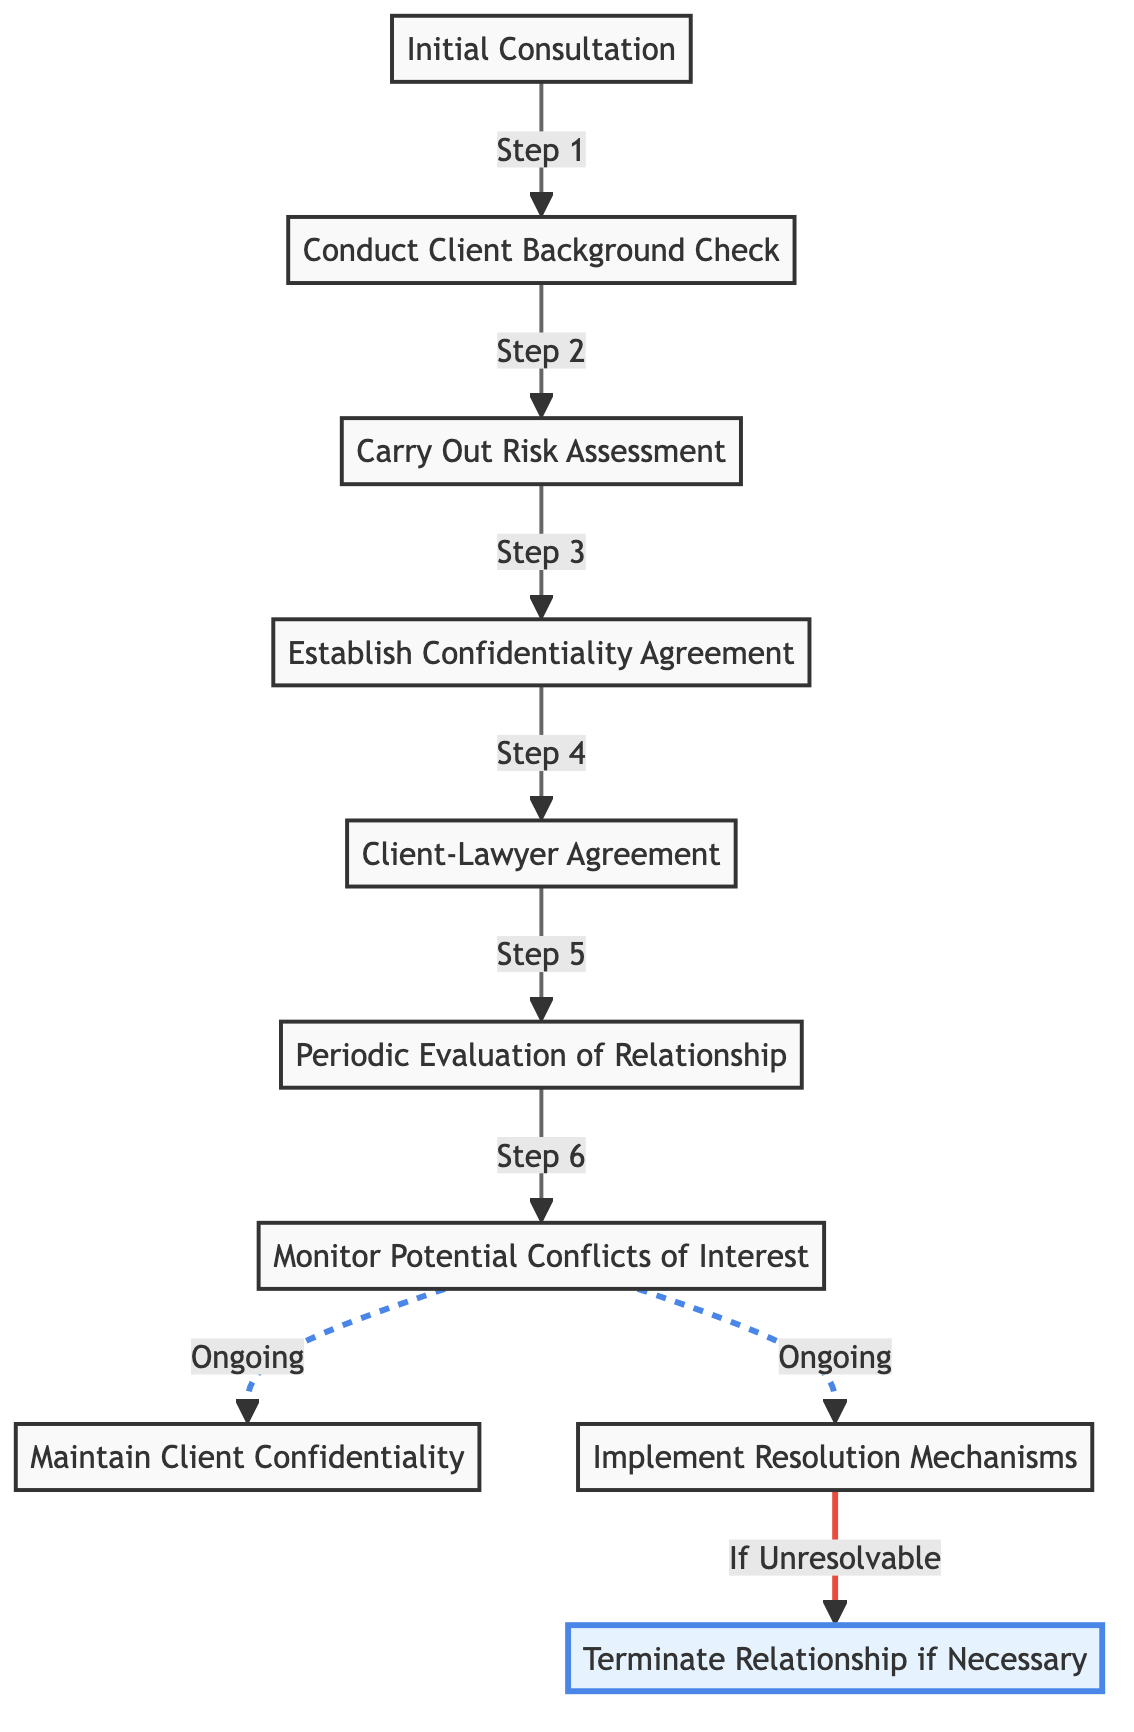What is the first stage in engaging with a controversial client? The diagram shows the first step as "Initial Consultation," which is the starting point of the client-lawyer relationship dynamics.
Answer: Initial Consultation How many main stages are shown in the diagram? The stages include Initial Consultation, Conduct Client Background Check, Carry Out Risk Assessment, Establish Confidentiality Agreement, Client-Lawyer Agreement, Periodic Evaluation of Relationship, Monitor Potential Conflicts of Interest, Maintain Client Confidentiality, and Implement Resolution Mechanisms, totaling to nine distinct stages.
Answer: Nine What step follows the 'Establish Confidentiality Agreement'? According to the flow of the diagram, after establishing a confidentiality agreement, the next step is "Client-Lawyer Agreement."
Answer: Client-Lawyer Agreement Which stage involves ongoing activities related to client conflicts? The diagram indicates that "Monitor Potential Conflicts of Interest" is the stage that leads to ongoing activities regarding conflicts, which includes maintaining client confidentiality and implementing resolution mechanisms.
Answer: Monitor Potential Conflicts of Interest What happens if issues are deemed unresolvable according to the diagram? The last step following the "Implement Resolution Mechanisms" is highlighted as "Terminate Relationship if Necessary," indicating that if issues cannot be resolved, termination of the relationship is an option.
Answer: Terminate Relationship if Necessary How is confidentiality addressed in the client-lawyer relationship according to the diagram? The diagram illustrates that establishing a "Confidentiality Agreement" is a dedicated step, followed by ongoing maintenance of client confidentiality. This signifies that confidentiality is both a defined agreement and a continuous obligation.
Answer: Establish Confidentiality Agreement What is the last property in the diagram related to maintaining the client-lawyer relationship? After evaluating the dynamic between the client and lawyer, the diagram concludes with "Maintain Client Confidentiality" as a crucial ongoing responsibility for the lawyer.
Answer: Maintain Client Confidentiality What is indicated by the dashed line in the diagram? The dashed lines signify ongoing activities related to potential conflicts, specifically highlighting the continuous nature of monitoring and implementing resolution mechanisms.
Answer: Ongoing activities 